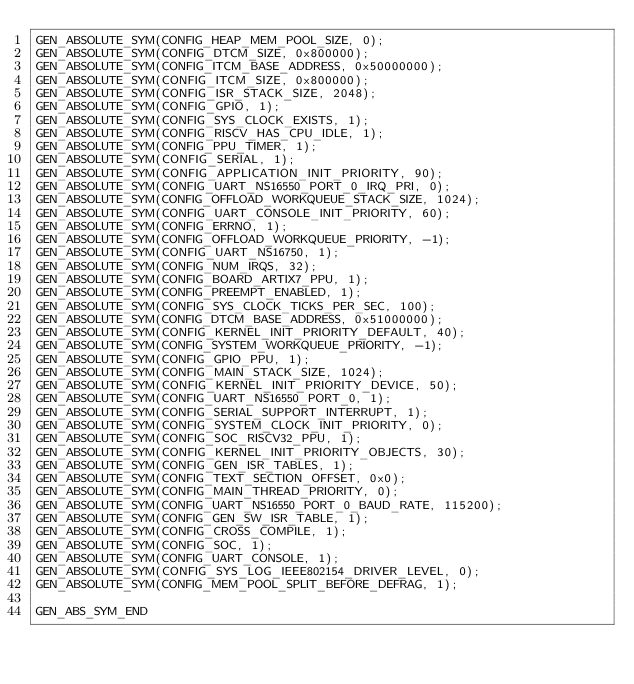<code> <loc_0><loc_0><loc_500><loc_500><_C_>GEN_ABSOLUTE_SYM(CONFIG_HEAP_MEM_POOL_SIZE, 0);
GEN_ABSOLUTE_SYM(CONFIG_DTCM_SIZE, 0x800000);
GEN_ABSOLUTE_SYM(CONFIG_ITCM_BASE_ADDRESS, 0x50000000);
GEN_ABSOLUTE_SYM(CONFIG_ITCM_SIZE, 0x800000);
GEN_ABSOLUTE_SYM(CONFIG_ISR_STACK_SIZE, 2048);
GEN_ABSOLUTE_SYM(CONFIG_GPIO, 1);
GEN_ABSOLUTE_SYM(CONFIG_SYS_CLOCK_EXISTS, 1);
GEN_ABSOLUTE_SYM(CONFIG_RISCV_HAS_CPU_IDLE, 1);
GEN_ABSOLUTE_SYM(CONFIG_PPU_TIMER, 1);
GEN_ABSOLUTE_SYM(CONFIG_SERIAL, 1);
GEN_ABSOLUTE_SYM(CONFIG_APPLICATION_INIT_PRIORITY, 90);
GEN_ABSOLUTE_SYM(CONFIG_UART_NS16550_PORT_0_IRQ_PRI, 0);
GEN_ABSOLUTE_SYM(CONFIG_OFFLOAD_WORKQUEUE_STACK_SIZE, 1024);
GEN_ABSOLUTE_SYM(CONFIG_UART_CONSOLE_INIT_PRIORITY, 60);
GEN_ABSOLUTE_SYM(CONFIG_ERRNO, 1);
GEN_ABSOLUTE_SYM(CONFIG_OFFLOAD_WORKQUEUE_PRIORITY, -1);
GEN_ABSOLUTE_SYM(CONFIG_UART_NS16750, 1);
GEN_ABSOLUTE_SYM(CONFIG_NUM_IRQS, 32);
GEN_ABSOLUTE_SYM(CONFIG_BOARD_ARTIX7_PPU, 1);
GEN_ABSOLUTE_SYM(CONFIG_PREEMPT_ENABLED, 1);
GEN_ABSOLUTE_SYM(CONFIG_SYS_CLOCK_TICKS_PER_SEC, 100);
GEN_ABSOLUTE_SYM(CONFIG_DTCM_BASE_ADDRESS, 0x51000000);
GEN_ABSOLUTE_SYM(CONFIG_KERNEL_INIT_PRIORITY_DEFAULT, 40);
GEN_ABSOLUTE_SYM(CONFIG_SYSTEM_WORKQUEUE_PRIORITY, -1);
GEN_ABSOLUTE_SYM(CONFIG_GPIO_PPU, 1);
GEN_ABSOLUTE_SYM(CONFIG_MAIN_STACK_SIZE, 1024);
GEN_ABSOLUTE_SYM(CONFIG_KERNEL_INIT_PRIORITY_DEVICE, 50);
GEN_ABSOLUTE_SYM(CONFIG_UART_NS16550_PORT_0, 1);
GEN_ABSOLUTE_SYM(CONFIG_SERIAL_SUPPORT_INTERRUPT, 1);
GEN_ABSOLUTE_SYM(CONFIG_SYSTEM_CLOCK_INIT_PRIORITY, 0);
GEN_ABSOLUTE_SYM(CONFIG_SOC_RISCV32_PPU, 1);
GEN_ABSOLUTE_SYM(CONFIG_KERNEL_INIT_PRIORITY_OBJECTS, 30);
GEN_ABSOLUTE_SYM(CONFIG_GEN_ISR_TABLES, 1);
GEN_ABSOLUTE_SYM(CONFIG_TEXT_SECTION_OFFSET, 0x0);
GEN_ABSOLUTE_SYM(CONFIG_MAIN_THREAD_PRIORITY, 0);
GEN_ABSOLUTE_SYM(CONFIG_UART_NS16550_PORT_0_BAUD_RATE, 115200);
GEN_ABSOLUTE_SYM(CONFIG_GEN_SW_ISR_TABLE, 1);
GEN_ABSOLUTE_SYM(CONFIG_CROSS_COMPILE, 1);
GEN_ABSOLUTE_SYM(CONFIG_SOC, 1);
GEN_ABSOLUTE_SYM(CONFIG_UART_CONSOLE, 1);
GEN_ABSOLUTE_SYM(CONFIG_SYS_LOG_IEEE802154_DRIVER_LEVEL, 0);
GEN_ABSOLUTE_SYM(CONFIG_MEM_POOL_SPLIT_BEFORE_DEFRAG, 1);

GEN_ABS_SYM_END
</code> 